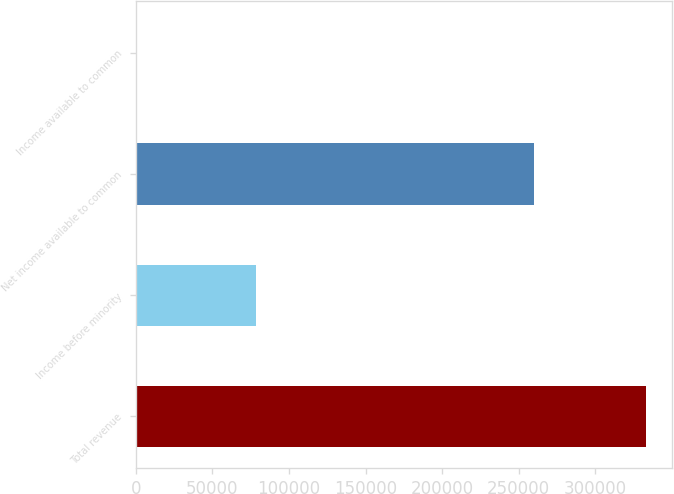Convert chart. <chart><loc_0><loc_0><loc_500><loc_500><bar_chart><fcel>Total revenue<fcel>Income before minority<fcel>Net income available to common<fcel>Income available to common<nl><fcel>333331<fcel>78720<fcel>260146<fcel>2.7<nl></chart> 